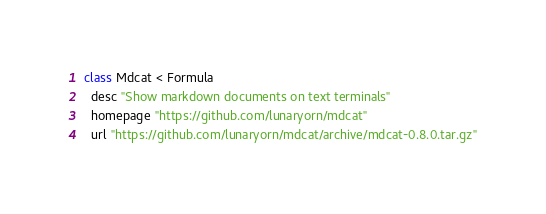Convert code to text. <code><loc_0><loc_0><loc_500><loc_500><_Ruby_>class Mdcat < Formula
  desc "Show markdown documents on text terminals"
  homepage "https://github.com/lunaryorn/mdcat"
  url "https://github.com/lunaryorn/mdcat/archive/mdcat-0.8.0.tar.gz"</code> 